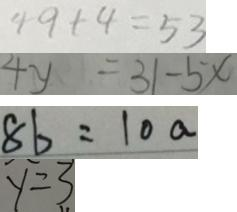<formula> <loc_0><loc_0><loc_500><loc_500>4 9 + 4 = 5 3 
 4 y = 3 1 - 5 x 
 8 b = 1 0 a 
 y = 3</formula> 